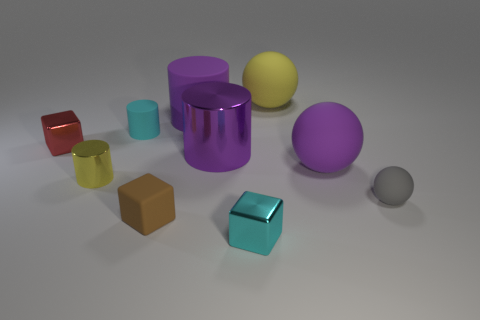Subtract all blocks. How many objects are left? 7 Add 9 tiny cyan shiny blocks. How many tiny cyan shiny blocks exist? 10 Subtract 0 purple blocks. How many objects are left? 10 Subtract all large red shiny cylinders. Subtract all cyan cylinders. How many objects are left? 9 Add 9 small gray spheres. How many small gray spheres are left? 10 